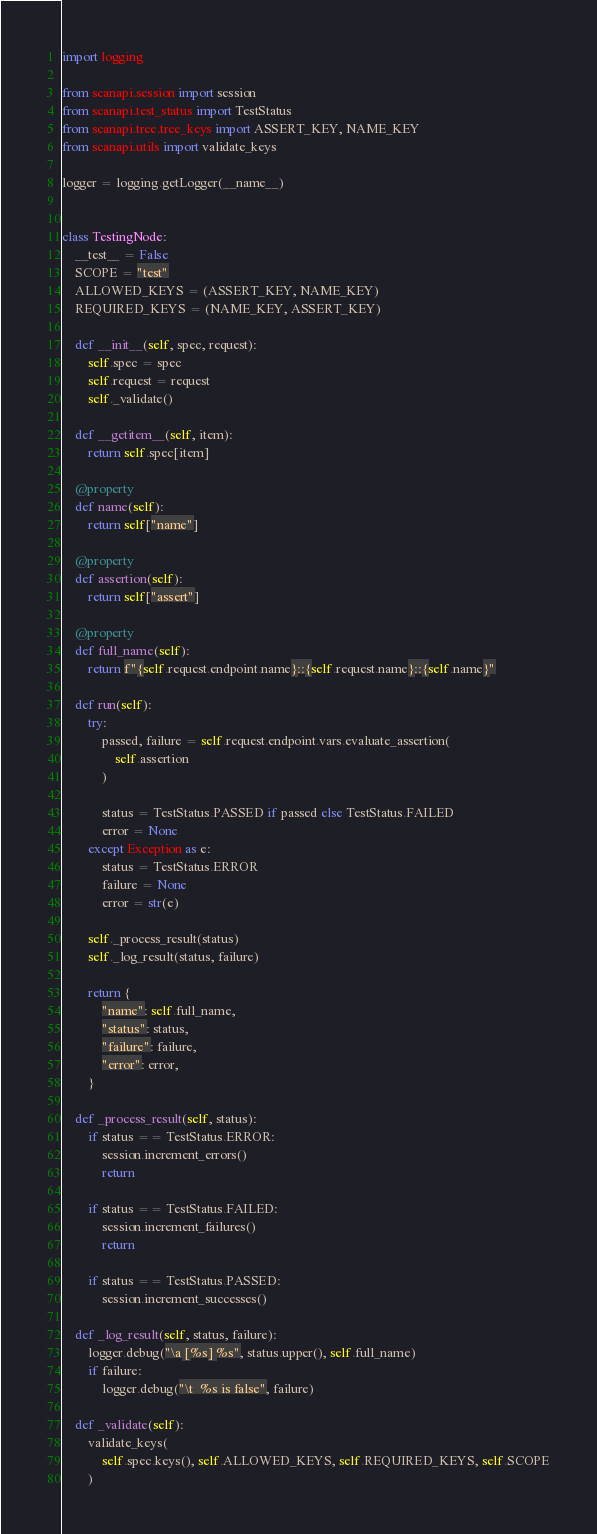<code> <loc_0><loc_0><loc_500><loc_500><_Python_>import logging

from scanapi.session import session
from scanapi.test_status import TestStatus
from scanapi.tree.tree_keys import ASSERT_KEY, NAME_KEY
from scanapi.utils import validate_keys

logger = logging.getLogger(__name__)


class TestingNode:
    __test__ = False
    SCOPE = "test"
    ALLOWED_KEYS = (ASSERT_KEY, NAME_KEY)
    REQUIRED_KEYS = (NAME_KEY, ASSERT_KEY)

    def __init__(self, spec, request):
        self.spec = spec
        self.request = request
        self._validate()

    def __getitem__(self, item):
        return self.spec[item]

    @property
    def name(self):
        return self["name"]

    @property
    def assertion(self):
        return self["assert"]

    @property
    def full_name(self):
        return f"{self.request.endpoint.name}::{self.request.name}::{self.name}"

    def run(self):
        try:
            passed, failure = self.request.endpoint.vars.evaluate_assertion(
                self.assertion
            )

            status = TestStatus.PASSED if passed else TestStatus.FAILED
            error = None
        except Exception as e:
            status = TestStatus.ERROR
            failure = None
            error = str(e)

        self._process_result(status)
        self._log_result(status, failure)

        return {
            "name": self.full_name,
            "status": status,
            "failure": failure,
            "error": error,
        }

    def _process_result(self, status):
        if status == TestStatus.ERROR:
            session.increment_errors()
            return

        if status == TestStatus.FAILED:
            session.increment_failures()
            return

        if status == TestStatus.PASSED:
            session.increment_successes()

    def _log_result(self, status, failure):
        logger.debug("\a [%s] %s", status.upper(), self.full_name)
        if failure:
            logger.debug("\t  %s is false", failure)

    def _validate(self):
        validate_keys(
            self.spec.keys(), self.ALLOWED_KEYS, self.REQUIRED_KEYS, self.SCOPE
        )
</code> 